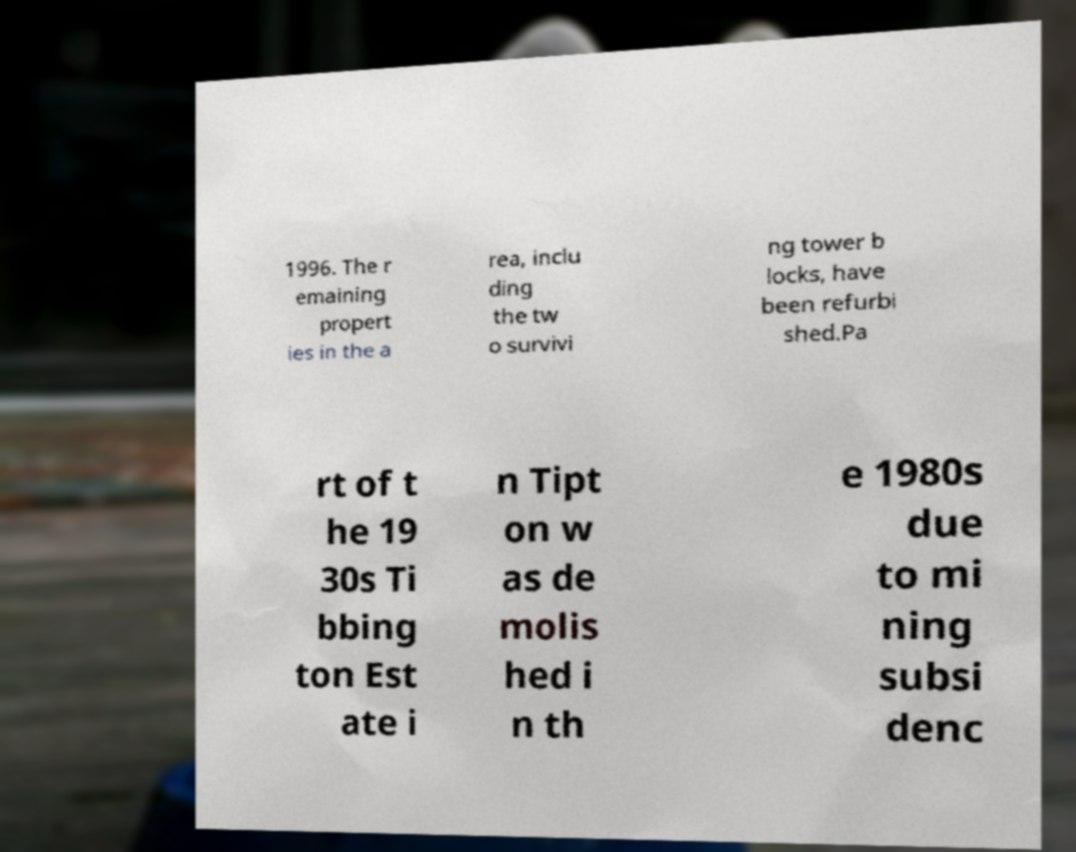Can you read and provide the text displayed in the image?This photo seems to have some interesting text. Can you extract and type it out for me? 1996. The r emaining propert ies in the a rea, inclu ding the tw o survivi ng tower b locks, have been refurbi shed.Pa rt of t he 19 30s Ti bbing ton Est ate i n Tipt on w as de molis hed i n th e 1980s due to mi ning subsi denc 